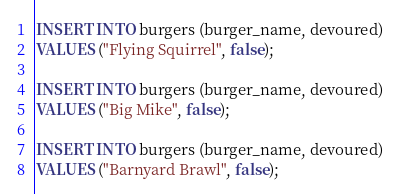<code> <loc_0><loc_0><loc_500><loc_500><_SQL_>
INSERT INTO burgers (burger_name, devoured)
VALUES ("Flying Squirrel", false);

INSERT INTO burgers (burger_name, devoured)
VALUES ("Big Mike", false);

INSERT INTO burgers (burger_name, devoured)
VALUES ("Barnyard Brawl", false);</code> 